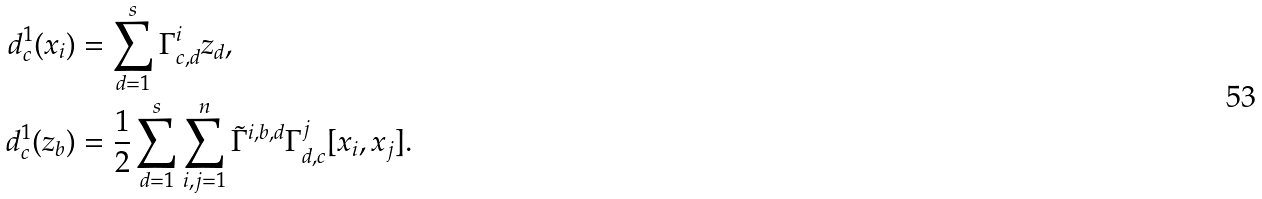Convert formula to latex. <formula><loc_0><loc_0><loc_500><loc_500>d _ { c } ^ { 1 } ( x _ { i } ) & = \sum _ { d = 1 } ^ { s } \Gamma ^ { i } _ { c , d } z _ { d } , \\ d _ { c } ^ { 1 } ( z _ { b } ) & = \frac { 1 } { 2 } \sum _ { d = 1 } ^ { s } \sum _ { i , j = 1 } ^ { n } \tilde { \Gamma } ^ { i , b , d } \Gamma ^ { j } _ { d , c } [ x _ { i } , x _ { j } ] .</formula> 